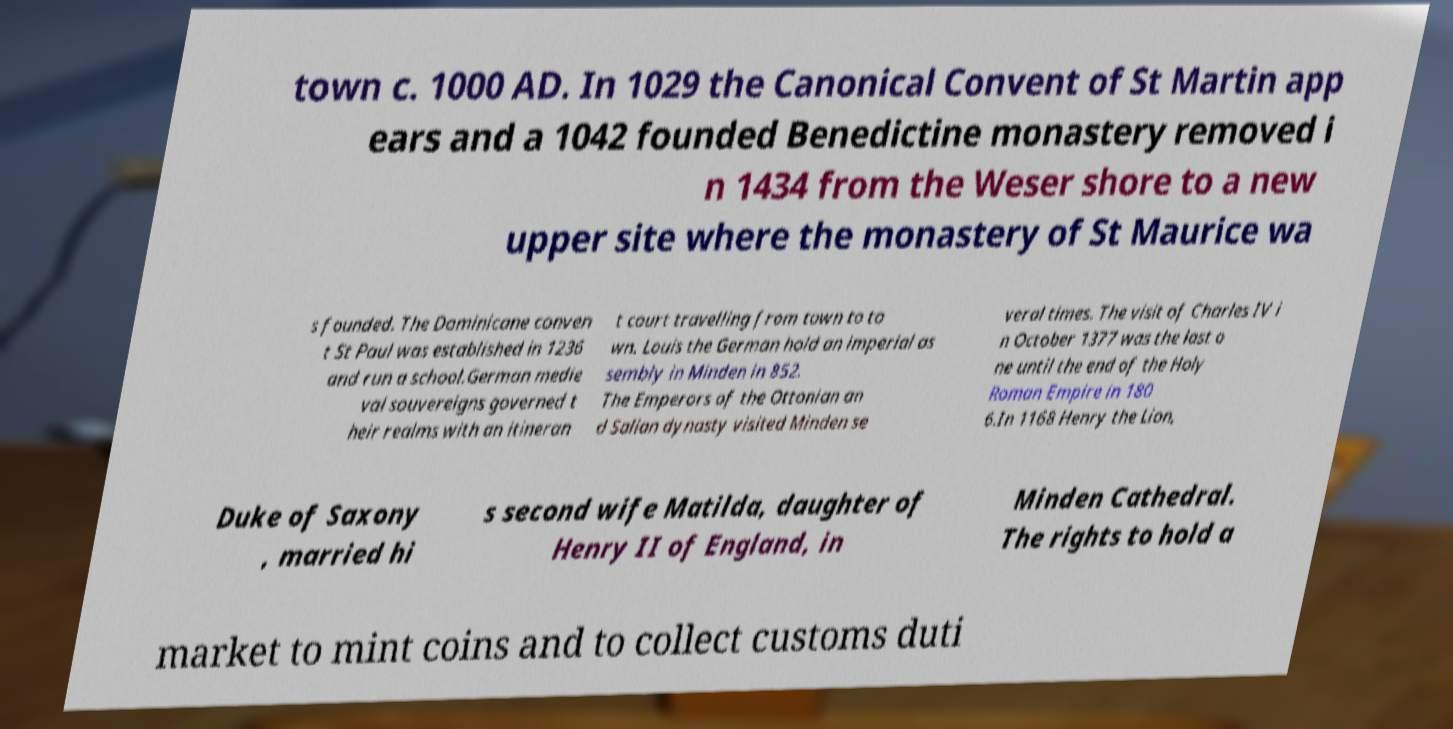Please read and relay the text visible in this image. What does it say? town c. 1000 AD. In 1029 the Canonical Convent of St Martin app ears and a 1042 founded Benedictine monastery removed i n 1434 from the Weser shore to a new upper site where the monastery of St Maurice wa s founded. The Dominicane conven t St Paul was established in 1236 and run a school.German medie val souvereigns governed t heir realms with an itineran t court travelling from town to to wn. Louis the German hold an imperial as sembly in Minden in 852. The Emperors of the Ottonian an d Salian dynasty visited Minden se veral times. The visit of Charles IV i n October 1377 was the last o ne until the end of the Holy Roman Empire in 180 6.In 1168 Henry the Lion, Duke of Saxony , married hi s second wife Matilda, daughter of Henry II of England, in Minden Cathedral. The rights to hold a market to mint coins and to collect customs duti 